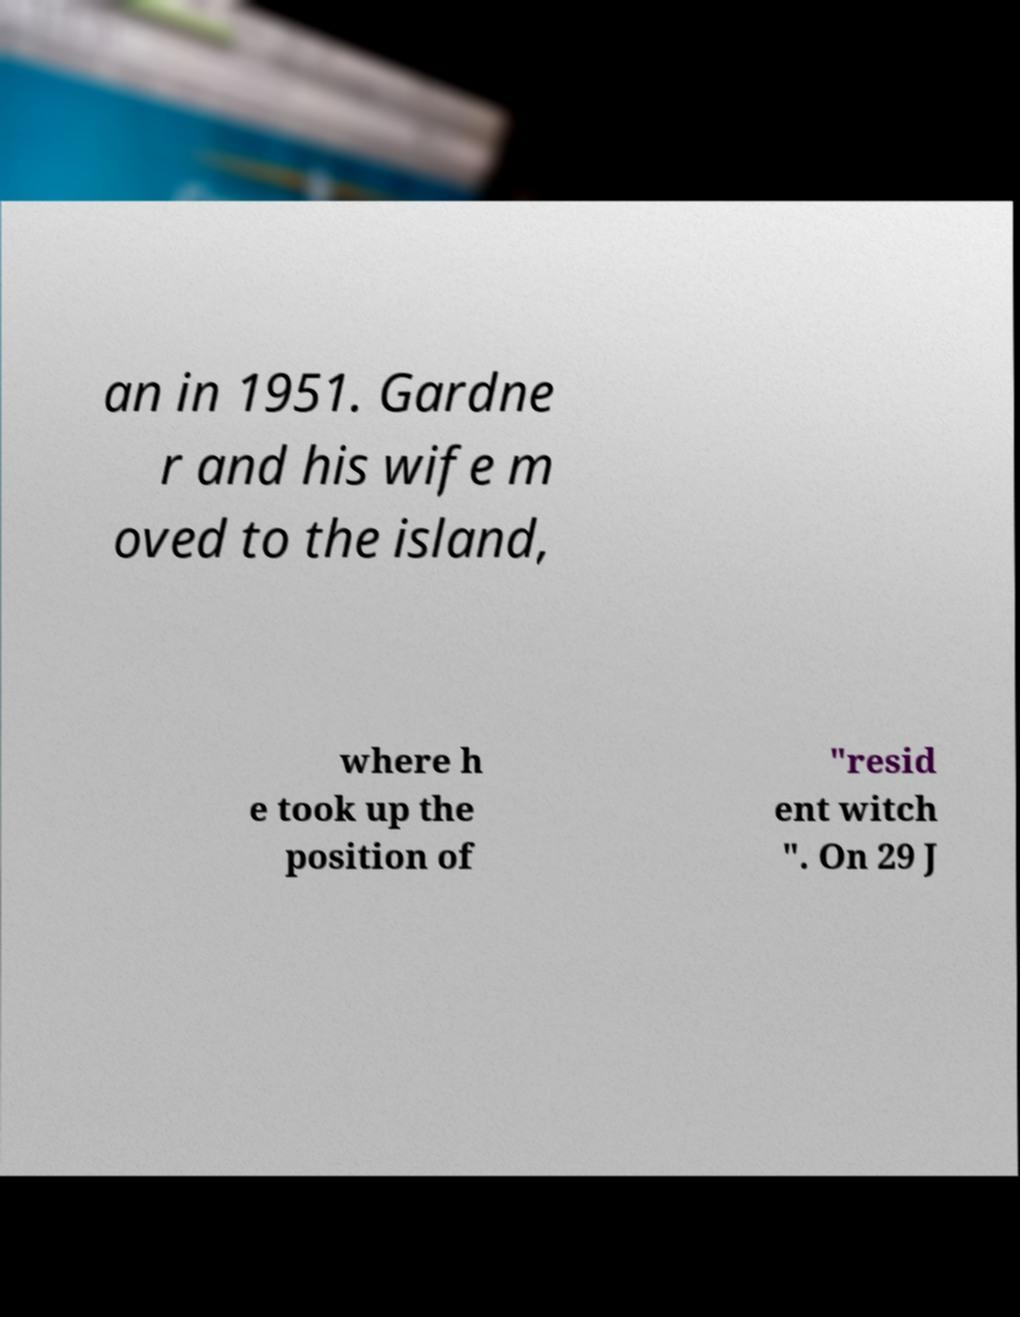I need the written content from this picture converted into text. Can you do that? an in 1951. Gardne r and his wife m oved to the island, where h e took up the position of "resid ent witch ". On 29 J 